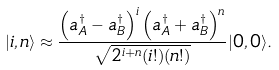<formula> <loc_0><loc_0><loc_500><loc_500>| i , n \rangle \approx \frac { \left ( a _ { A } ^ { \dag } - a _ { B } ^ { \dag } \right ) ^ { i } \left ( a _ { A } ^ { \dag } + a _ { B } ^ { \dag } \right ) ^ { n } } { \sqrt { 2 ^ { i + n } ( i ! ) ( n ! ) } } | 0 , 0 \rangle .</formula> 